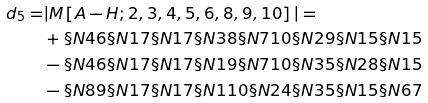<formula> <loc_0><loc_0><loc_500><loc_500>d _ { 5 } = & | M \left [ A - H ; 2 , 3 , 4 , 5 , 6 , 8 , 9 , 1 0 \right ] | = \\ & + \S N { 4 } { 6 } \S N { 1 } { 7 } \S N { 1 } { 7 } \S N { 3 } { 8 } \S N { 7 } { 1 0 } \S N { 2 } { 9 } \S N { 1 } { 5 } \S N { 1 } { 5 } \\ & - \S N { 4 } { 6 } \S N { 1 } { 7 } \S N { 1 } { 7 } \S N { 1 } { 9 } \S N { 7 } { 1 0 } \S N { 3 } { 5 } \S N { 2 } { 8 } \S N { 1 } { 5 } \\ & - \S N { 8 } { 9 } \S N { 1 } { 7 } \S N { 1 } { 7 } \S N { 1 } { 1 0 } \S N { 2 } { 4 } \S N { 3 } { 5 } \S N { 1 } { 5 } \S N { 6 } { 7 }</formula> 